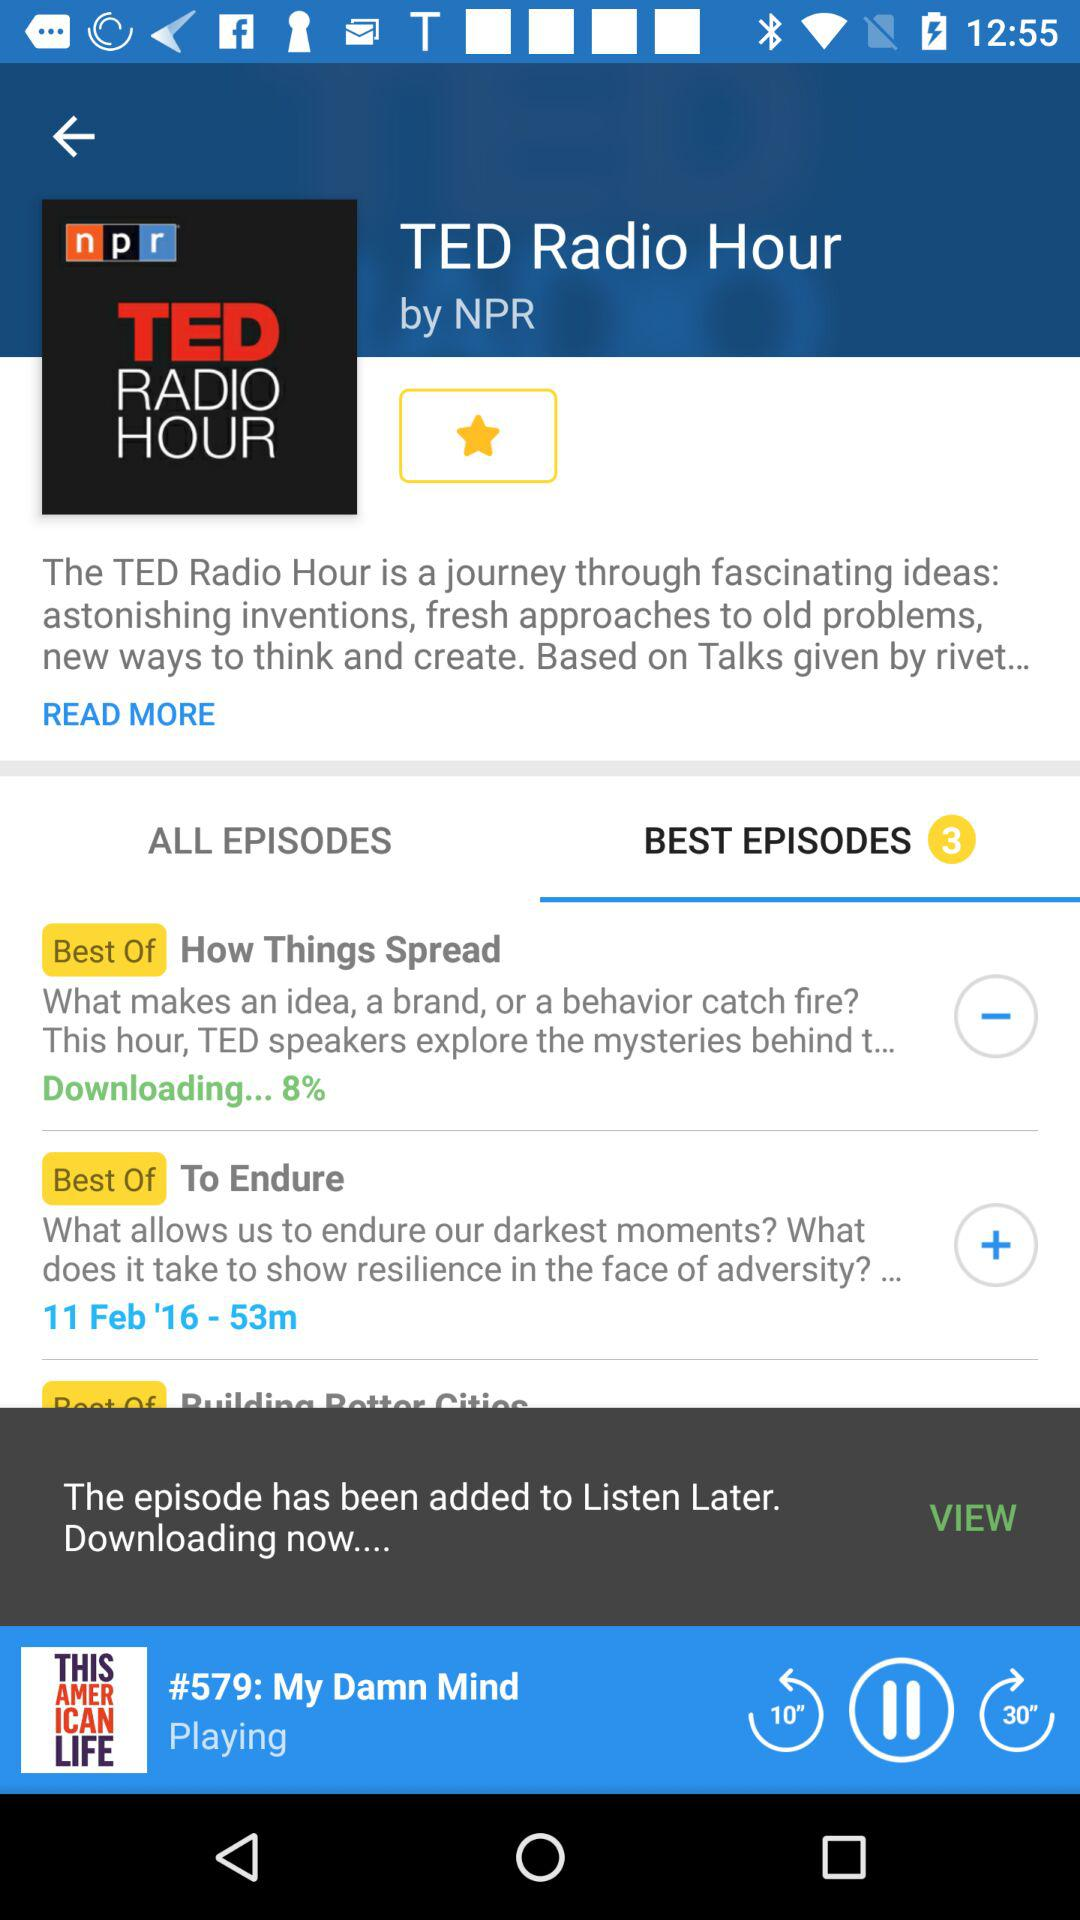What percentage of "How Things Spread" has been downloaded? The percentage of "How Things Spread" that has been downloaded is 8. 